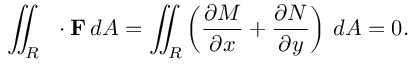<formula> <loc_0><loc_0><loc_500><loc_500>\iint _ { R } \, \nabla \cdot F \, d A = \iint _ { R } \left ( { \frac { \partial M } { \partial x } } + { \frac { \partial N } { \partial y } } \right ) \, d A = 0 .</formula> 